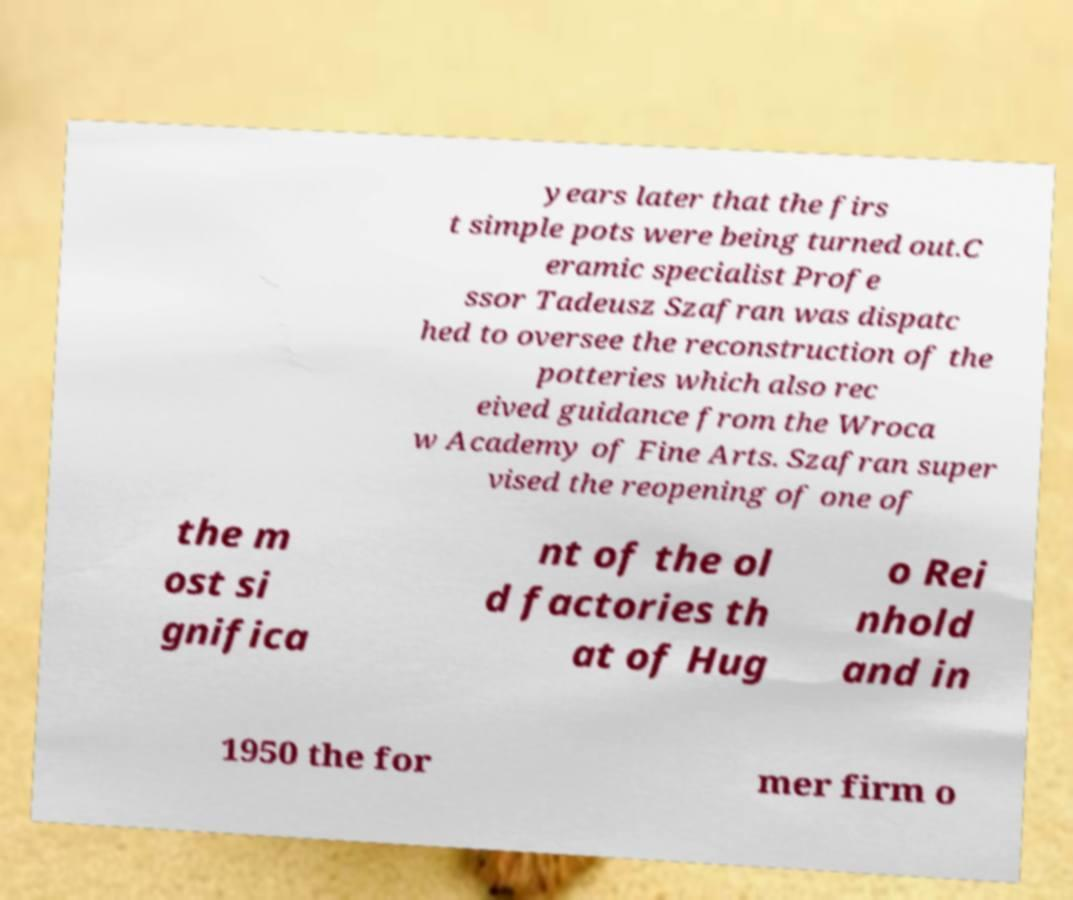What messages or text are displayed in this image? I need them in a readable, typed format. years later that the firs t simple pots were being turned out.C eramic specialist Profe ssor Tadeusz Szafran was dispatc hed to oversee the reconstruction of the potteries which also rec eived guidance from the Wroca w Academy of Fine Arts. Szafran super vised the reopening of one of the m ost si gnifica nt of the ol d factories th at of Hug o Rei nhold and in 1950 the for mer firm o 